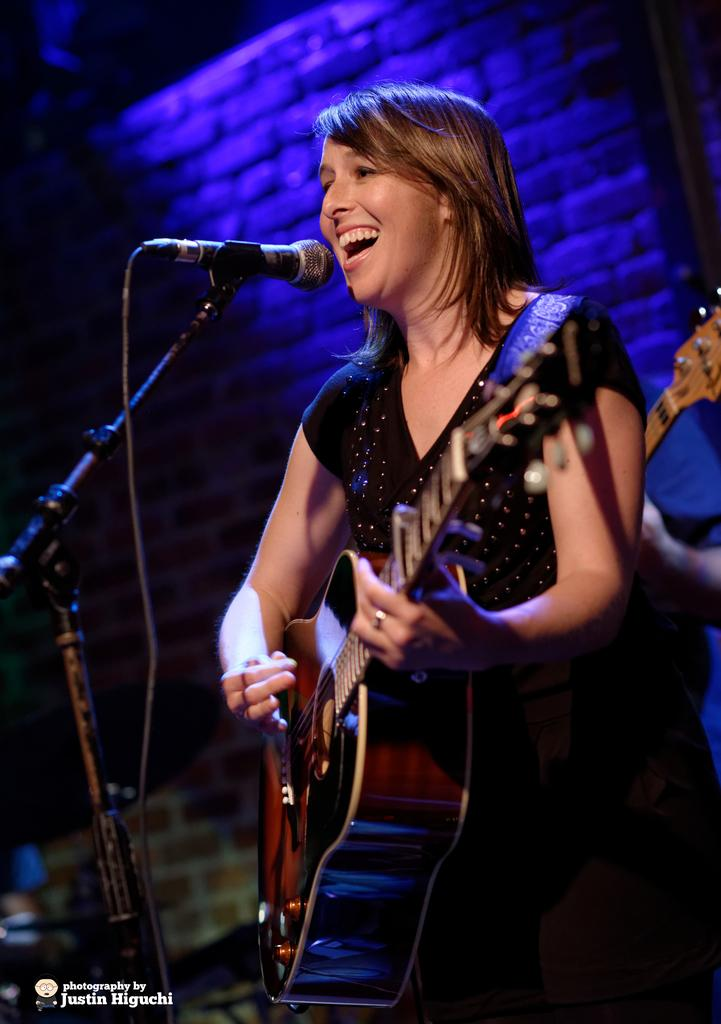Who is the main subject in the image? There is a woman in the image. What is the woman holding in the image? The woman is holding a guitar. What expression does the woman have on her face? The woman has a smile on her face. What object is in front of the woman? There is a microphone in front of her. What type of dish is the woman's father cooking in the image? There is no mention of a father or cooking in the image; it features a woman holding a guitar and standing near a microphone. Can you tell me how many pigs are present in the image? There are no pigs present in the image. 